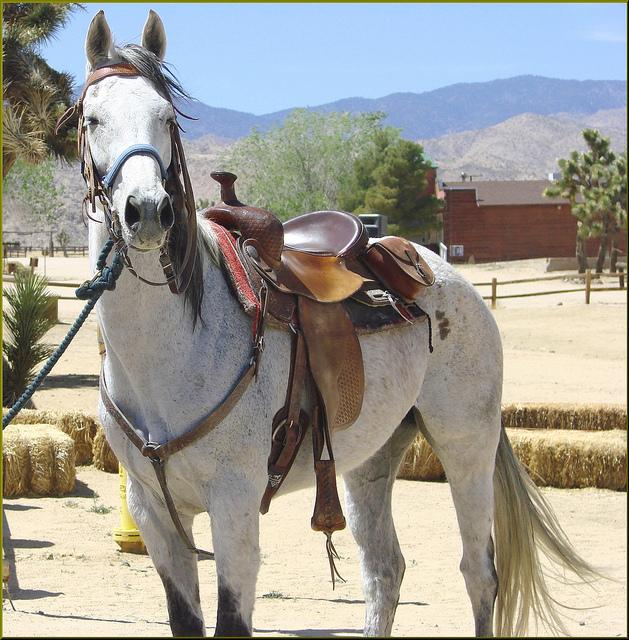Is there a man on the horse?
Keep it brief. No. What is on the horse's back?
Be succinct. Saddle. Are there mountains in the background?
Concise answer only. Yes. 